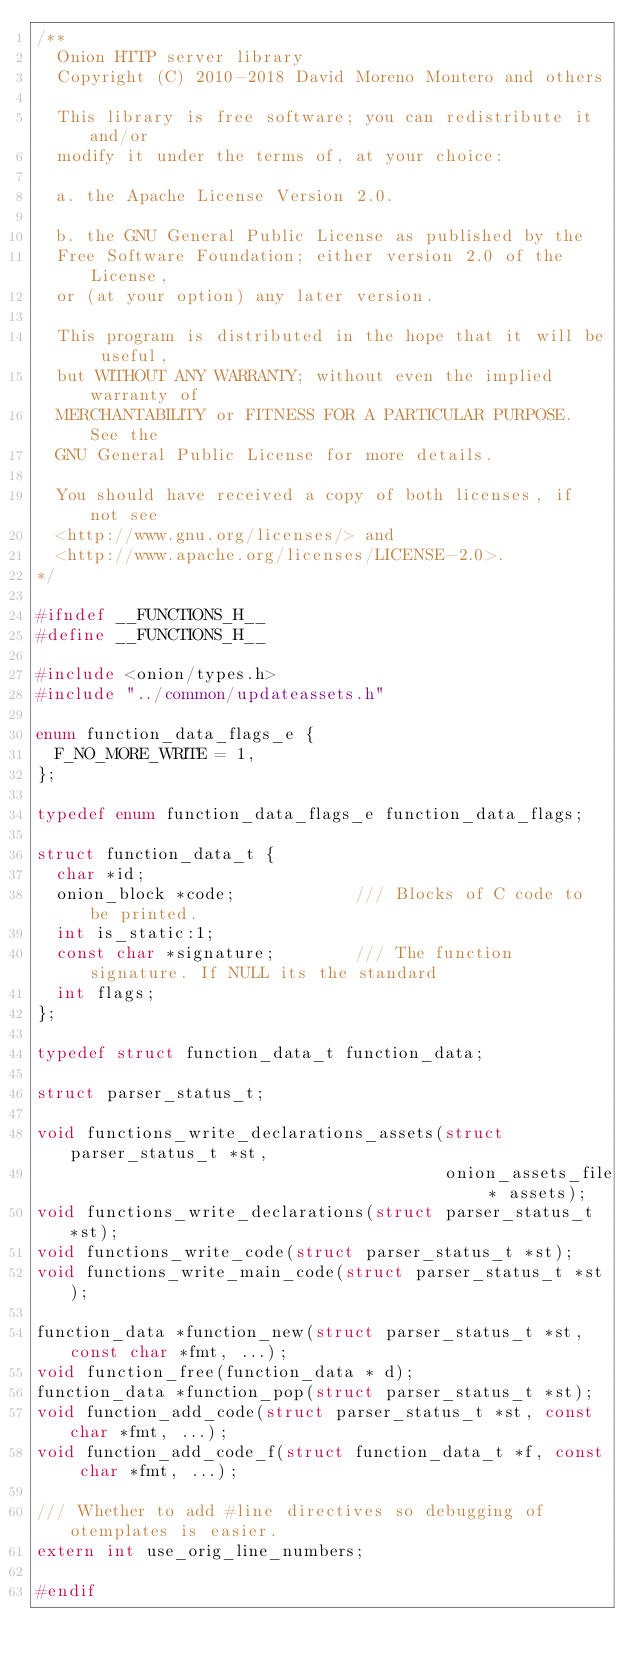<code> <loc_0><loc_0><loc_500><loc_500><_C_>/**
  Onion HTTP server library
  Copyright (C) 2010-2018 David Moreno Montero and others

  This library is free software; you can redistribute it and/or
  modify it under the terms of, at your choice:

  a. the Apache License Version 2.0.

  b. the GNU General Public License as published by the
  Free Software Foundation; either version 2.0 of the License,
  or (at your option) any later version.

  This program is distributed in the hope that it will be useful,
  but WITHOUT ANY WARRANTY; without even the implied warranty of
  MERCHANTABILITY or FITNESS FOR A PARTICULAR PURPOSE.  See the
  GNU General Public License for more details.

  You should have received a copy of both licenses, if not see
  <http://www.gnu.org/licenses/> and
  <http://www.apache.org/licenses/LICENSE-2.0>.
*/

#ifndef __FUNCTIONS_H__
#define __FUNCTIONS_H__

#include <onion/types.h>
#include "../common/updateassets.h"

enum function_data_flags_e {
  F_NO_MORE_WRITE = 1,
};

typedef enum function_data_flags_e function_data_flags;

struct function_data_t {
  char *id;
  onion_block *code;            /// Blocks of C code to be printed.
  int is_static:1;
  const char *signature;        /// The function signature. If NULL its the standard
  int flags;
};

typedef struct function_data_t function_data;

struct parser_status_t;

void functions_write_declarations_assets(struct parser_status_t *st,
                                         onion_assets_file * assets);
void functions_write_declarations(struct parser_status_t *st);
void functions_write_code(struct parser_status_t *st);
void functions_write_main_code(struct parser_status_t *st);

function_data *function_new(struct parser_status_t *st, const char *fmt, ...);
void function_free(function_data * d);
function_data *function_pop(struct parser_status_t *st);
void function_add_code(struct parser_status_t *st, const char *fmt, ...);
void function_add_code_f(struct function_data_t *f, const char *fmt, ...);

/// Whether to add #line directives so debugging of otemplates is easier.
extern int use_orig_line_numbers;

#endif
</code> 